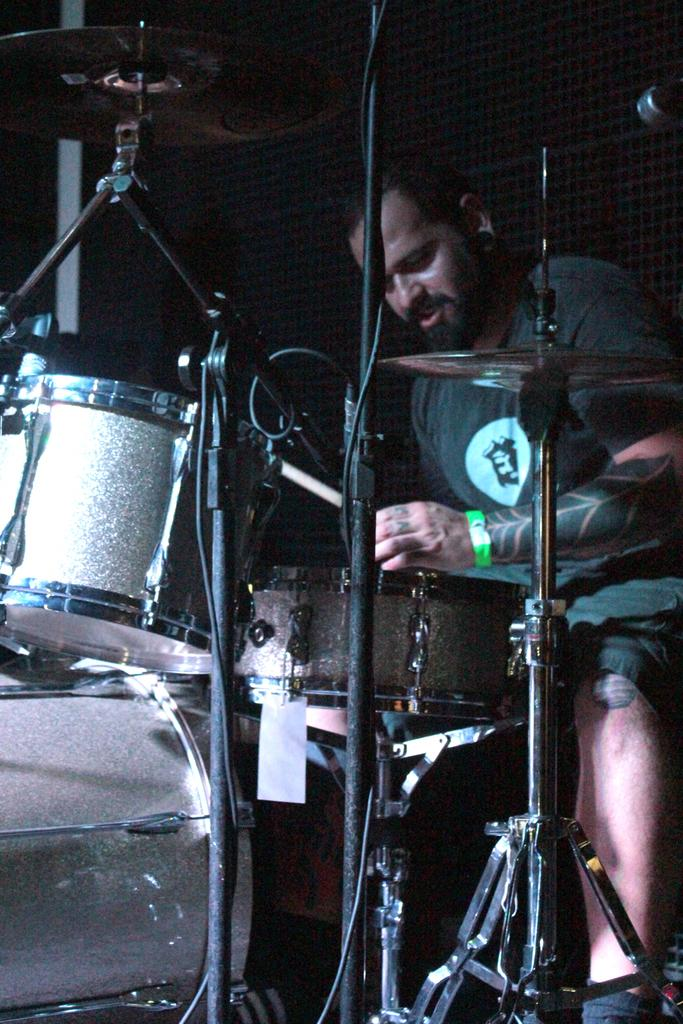What is the main subject of the image? There is a person in the image. What is the person doing in the image? The person is playing musical instruments. What can be seen in the background of the image? There is a wall in the background of the image. How many bears are visible in the image? There are no bears present in the image. What type of soap is being used by the person in the image? There is no soap present in the image, as the person is playing musical instruments. 